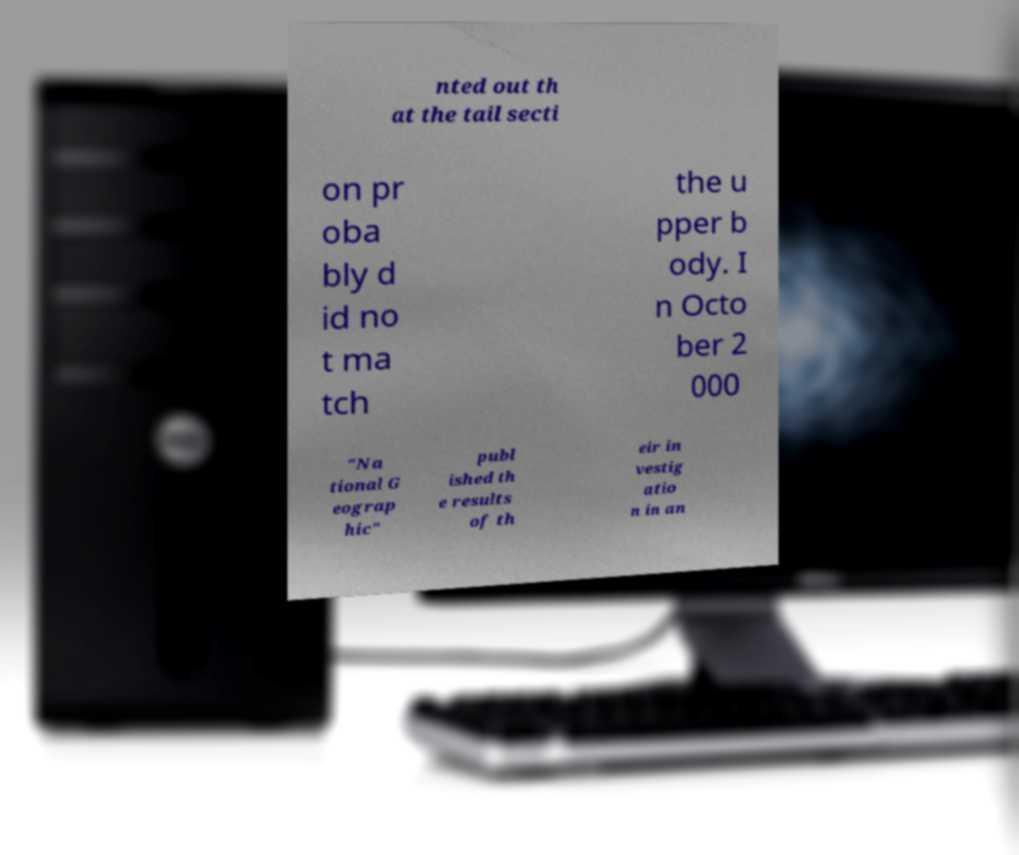Can you accurately transcribe the text from the provided image for me? nted out th at the tail secti on pr oba bly d id no t ma tch the u pper b ody. I n Octo ber 2 000 "Na tional G eograp hic" publ ished th e results of th eir in vestig atio n in an 